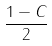<formula> <loc_0><loc_0><loc_500><loc_500>\frac { 1 - C } { 2 }</formula> 